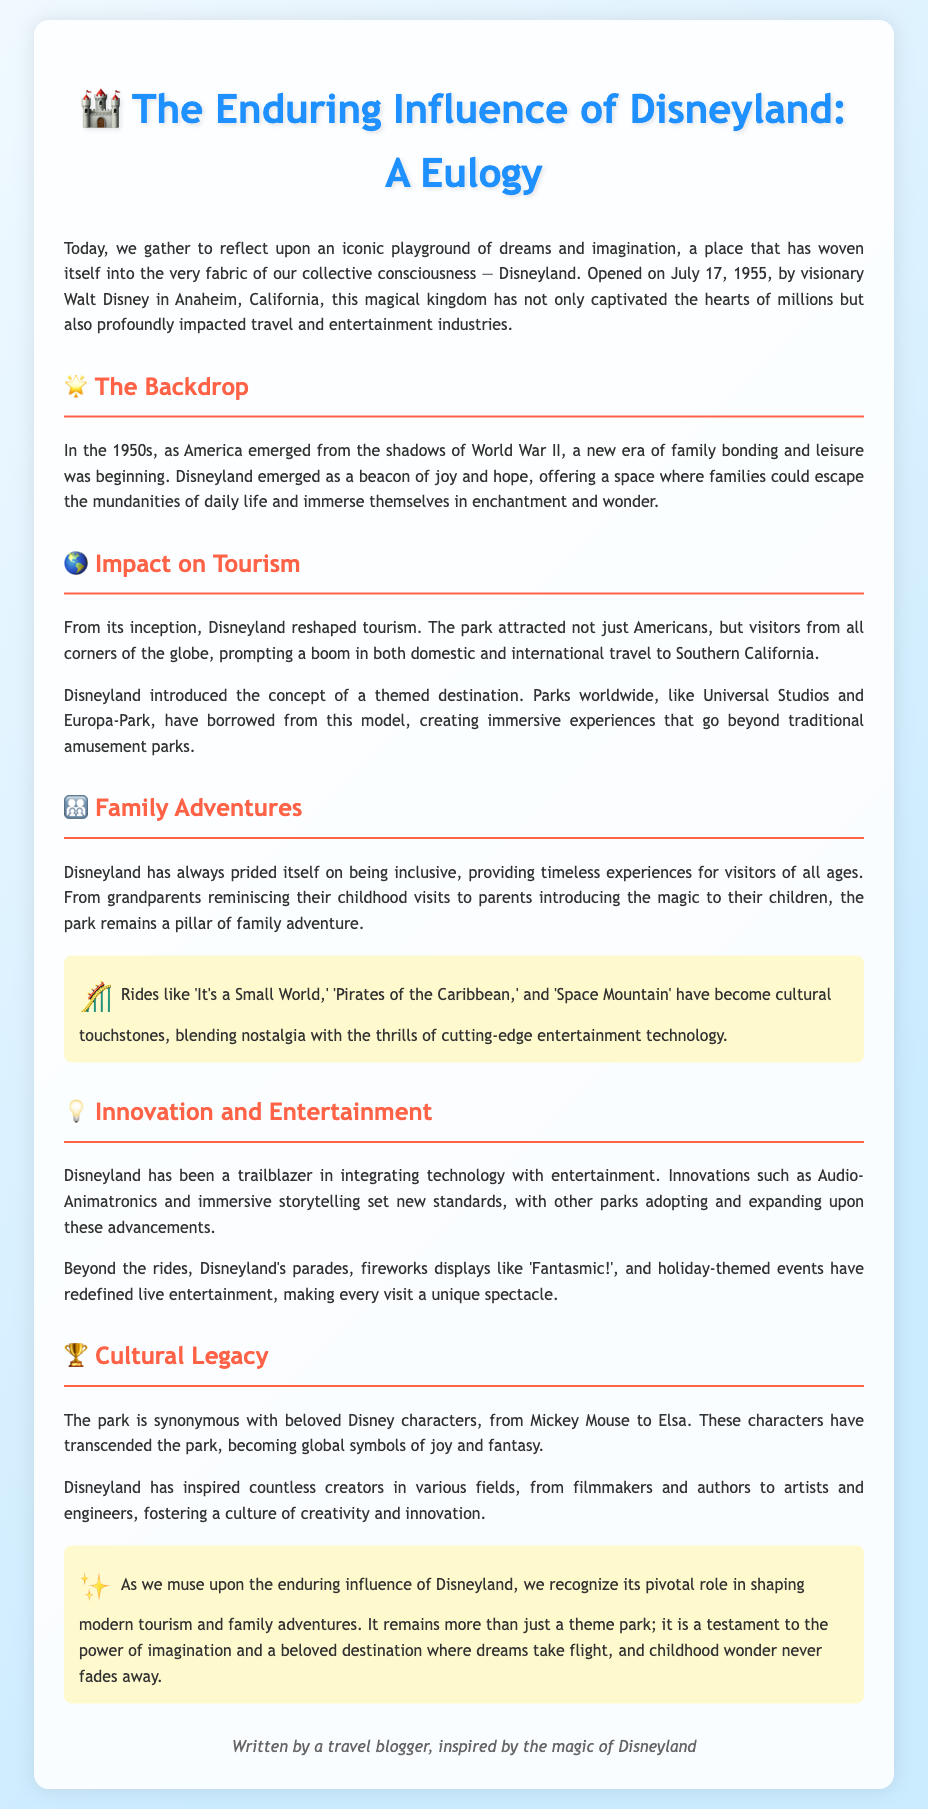What date did Disneyland open? The document states that Disneyland was opened on July 17, 1955.
Answer: July 17, 1955 Who founded Disneyland? It mentions that Disneyland was opened by visionary Walt Disney.
Answer: Walt Disney What type of experiences does Disneyland provide for families? The document discusses timeless experiences for visitors of all ages, emphasizing family bonding and adventure.
Answer: Timeless experiences Which technological innovation is mentioned in relation to Disneyland? The document highlights Audio-Animatronics as a significant innovation in integrating technology with entertainment.
Answer: Audio-Animatronics What has Disneyland inspired in various fields? It states that Disneyland has inspired countless creators, fostering a culture of creativity and innovation.
Answer: Creativity and innovation How did Disneyland impact tourism? The document mentions that Disneyland attracted visitors from all corners of the globe, prompting a boom in travel to Southern California.
Answer: Boom in travel What character is synonymously associated with Disneyland? The eulogy refers to Mickey Mouse as a beloved character synonymous with Disneyland.
Answer: Mickey Mouse What is a key theme of the document? The focus of the document revolves around the enduring influence of Disneyland on modern tourism and family adventures.
Answer: Enduring influence 